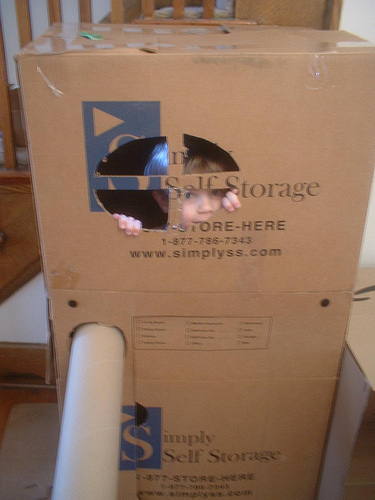<image>
Can you confirm if the kid is in front of the box? No. The kid is not in front of the box. The spatial positioning shows a different relationship between these objects. 